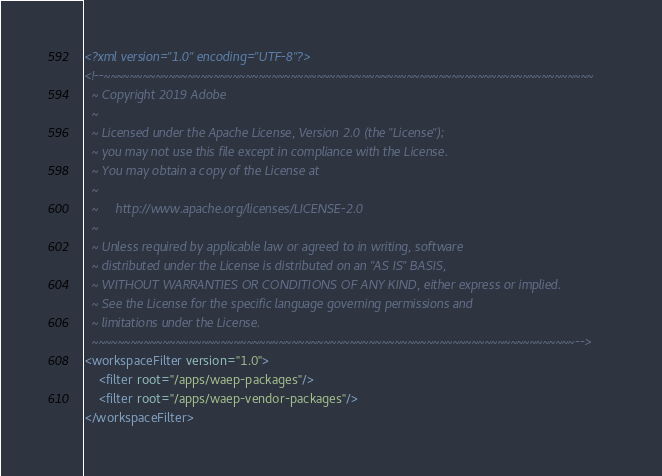<code> <loc_0><loc_0><loc_500><loc_500><_XML_><?xml version="1.0" encoding="UTF-8"?>
<!--~~~~~~~~~~~~~~~~~~~~~~~~~~~~~~~~~~~~~~~~~~~~~~~~~~~~~~~~~~~~~~~~~~~~~~~~~~~~
  ~ Copyright 2019 Adobe
  ~
  ~ Licensed under the Apache License, Version 2.0 (the "License");
  ~ you may not use this file except in compliance with the License.
  ~ You may obtain a copy of the License at
  ~
  ~     http://www.apache.org/licenses/LICENSE-2.0
  ~
  ~ Unless required by applicable law or agreed to in writing, software
  ~ distributed under the License is distributed on an "AS IS" BASIS,
  ~ WITHOUT WARRANTIES OR CONDITIONS OF ANY KIND, either express or implied.
  ~ See the License for the specific language governing permissions and
  ~ limitations under the License.
  ~~~~~~~~~~~~~~~~~~~~~~~~~~~~~~~~~~~~~~~~~~~~~~~~~~~~~~~~~~~~~~~~~~~~~~~~~~~-->
<workspaceFilter version="1.0">
    <filter root="/apps/waep-packages"/>
    <filter root="/apps/waep-vendor-packages"/>
</workspaceFilter>
</code> 